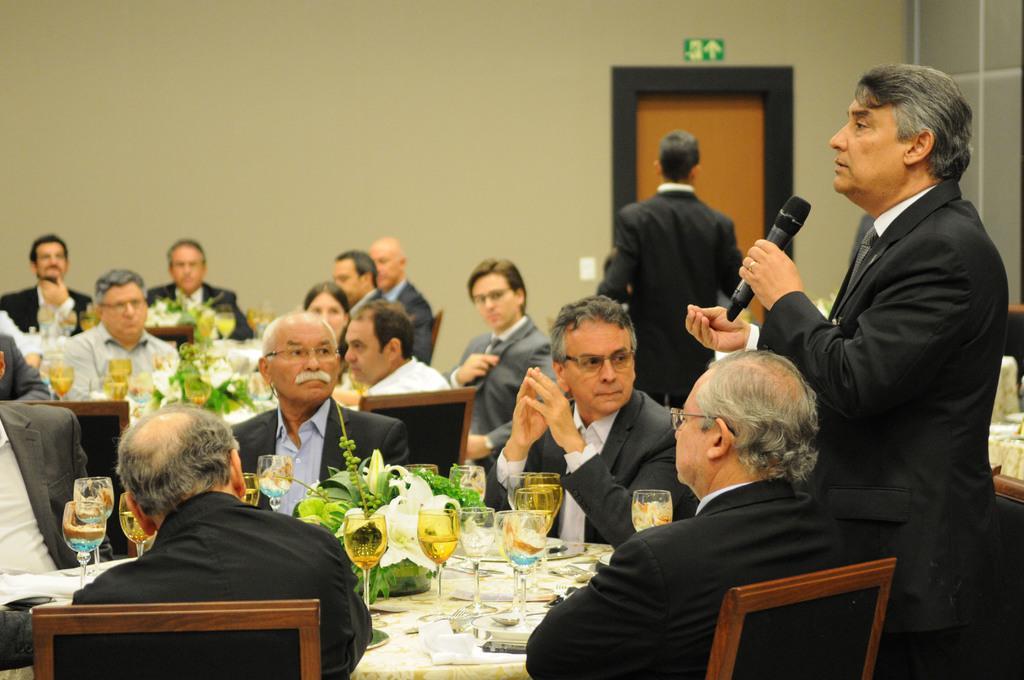How would you summarize this image in a sentence or two? In the image few persons are sitting on a chair and there are two persons on standing and this person holding a microphone in his hands. Top left side of the image there is a wall. In the middle of the image there is a table, On the table there are some glasses. 